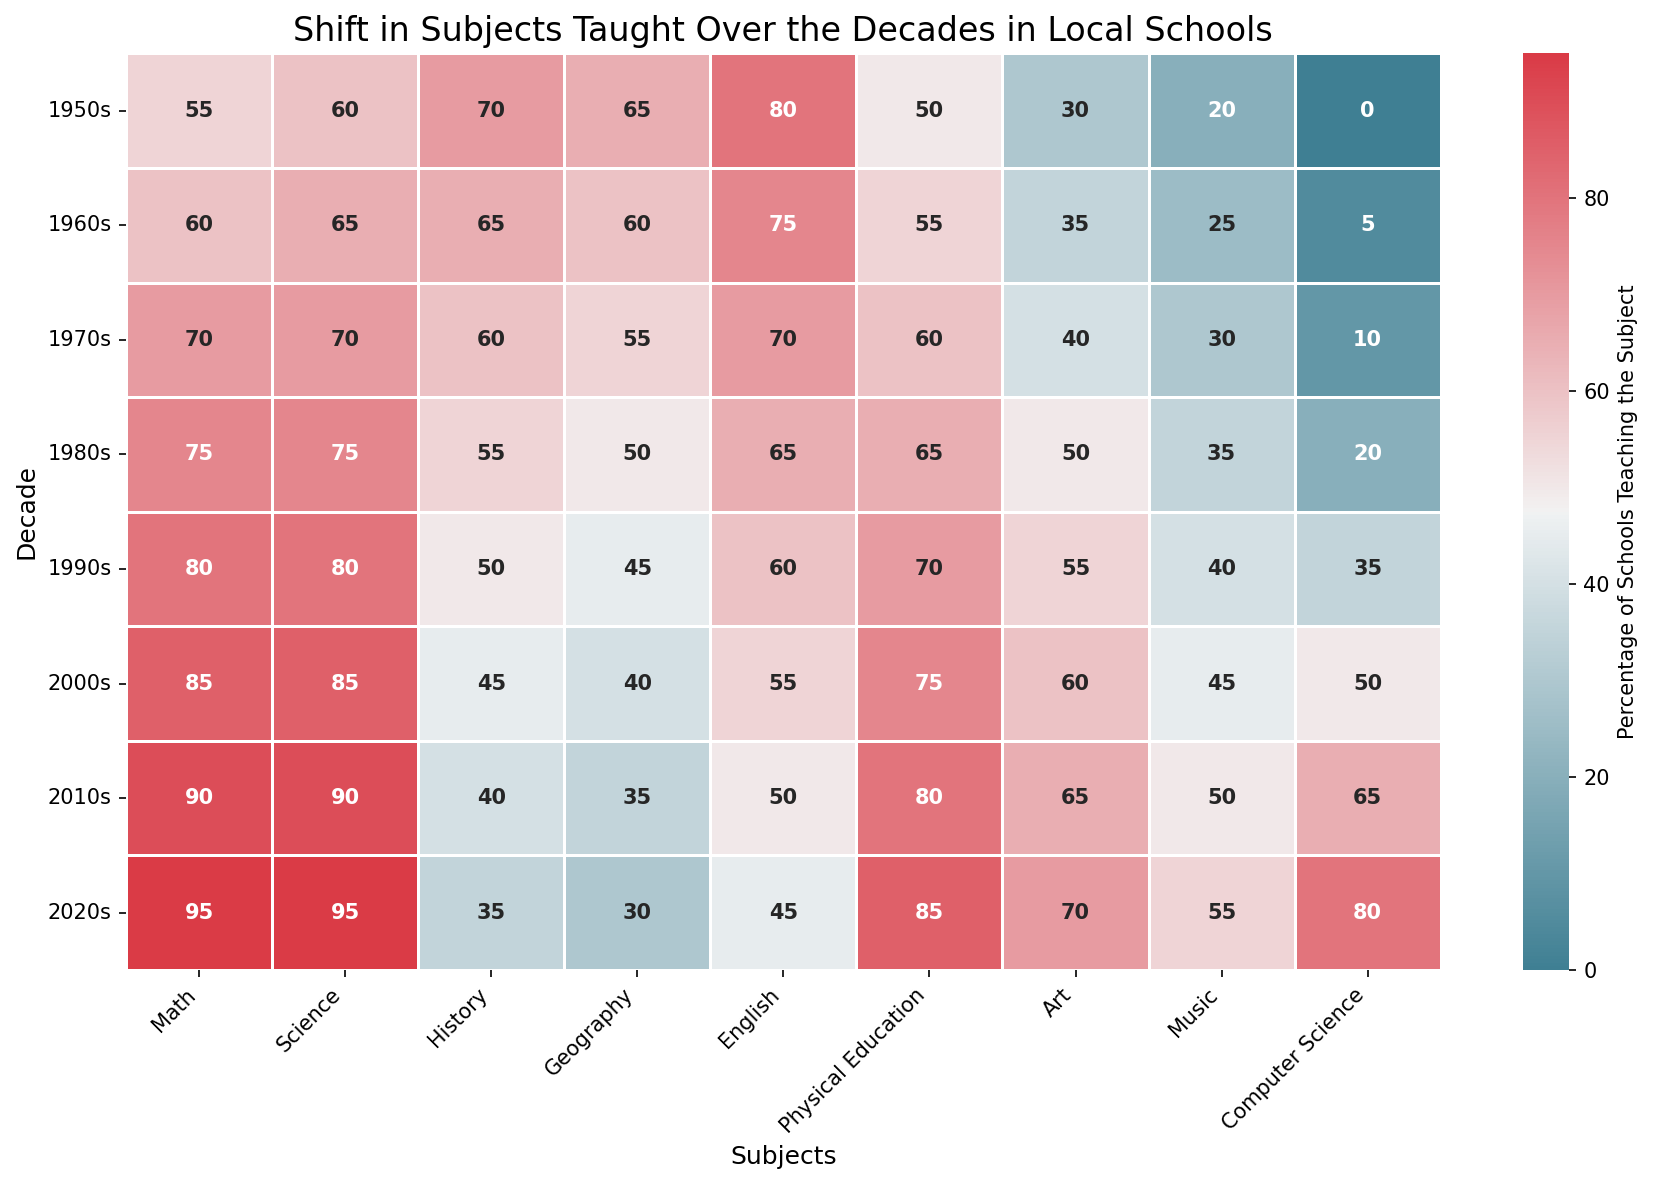Which subject has seen the largest increase in teaching percentage from the 1950s to the 2020s? To find the subject with the largest increase, subtract the 1950s value from the 2020s value for each subject and identify the largest result: Math (95-55=40), Science (95-60=35), History (35-70=-35), Geography (30-65=-35), English (45-80=-35), Physical Education (85-50=35), Art (70-30=40), Music (55-20=35), Computer Science (80-0=80). The largest increase is for Computer Science.
Answer: Computer Science Which decade had the lowest percentage of schools teaching Geography? Look for the smallest value in the Geography column. The values are 65, 60, 55, 50, 45, 40, 35, 30 for the decades from the 1950s to the 2020s respectively. The lowest value is 30 in the 2020s.
Answer: 2020s In which decade did Music surpass Art in teaching percentage for the first time? Compare the values of Music and Art for each decade and find the first instance where Music's percentage is greater than Art's: 1950s (20 < 30), 1960s (25 < 35), 1970s (30 = 40), 1980s (35 < 50), 1990s (40 < 55), 2000s (45 < 60), 2010s (50 < 65), 2020s (55 < 70). Music never surpasses Art.
Answer: Never What's the average percentage of schools teaching Physical Education across all decades? Add up the values for Physical Education and divide by the number of decades: (50+55+60+65+70+75+80+85)/8 = 540/8 = 67.5.
Answer: 67.5 Which subject had the greatest decrease in teaching percentage from the 1950s to the 2020s? To find the subject with the greatest decrease, subtract the 2020s value from the 1950s value for each subject and identify the largest result: Math (55-95=-40), Science (60-95=-35), History (70-35=35), Geography (65-30=35), English (80-45=35), Physical Education (50-85=-35), Art (30-70=-40), Music (20-55=-35), Computer Science (0-80=-80). The greatest decrease is for Computer Science.
Answer: Computer Science In which decade did the percentage of schools teaching Computer Science reach 50% or more? Identify the first decade where the percentage for Computer Science is 50 or greater: 1950s (0), 1960s (5), 1970s (10), 1980s (20), 1990s (35), 2000s (50), 2010s (65), 2020s (80). The first decade is the 2000s.
Answer: 2000s What's the median percentage of schools teaching English across all decades? Order the percentages for English and find the middle value: 80, 75, 70, 65, 60, 55, 50, 45. To find the median, take the middle two values (60+55)/2 = 57.5.
Answer: 57.5 